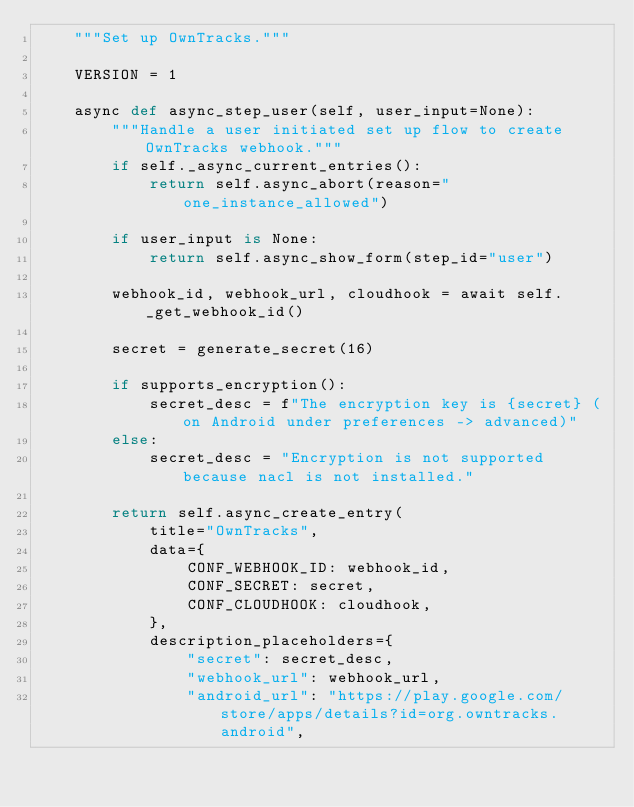Convert code to text. <code><loc_0><loc_0><loc_500><loc_500><_Python_>    """Set up OwnTracks."""

    VERSION = 1

    async def async_step_user(self, user_input=None):
        """Handle a user initiated set up flow to create OwnTracks webhook."""
        if self._async_current_entries():
            return self.async_abort(reason="one_instance_allowed")

        if user_input is None:
            return self.async_show_form(step_id="user")

        webhook_id, webhook_url, cloudhook = await self._get_webhook_id()

        secret = generate_secret(16)

        if supports_encryption():
            secret_desc = f"The encryption key is {secret} (on Android under preferences -> advanced)"
        else:
            secret_desc = "Encryption is not supported because nacl is not installed."

        return self.async_create_entry(
            title="OwnTracks",
            data={
                CONF_WEBHOOK_ID: webhook_id,
                CONF_SECRET: secret,
                CONF_CLOUDHOOK: cloudhook,
            },
            description_placeholders={
                "secret": secret_desc,
                "webhook_url": webhook_url,
                "android_url": "https://play.google.com/store/apps/details?id=org.owntracks.android",</code> 